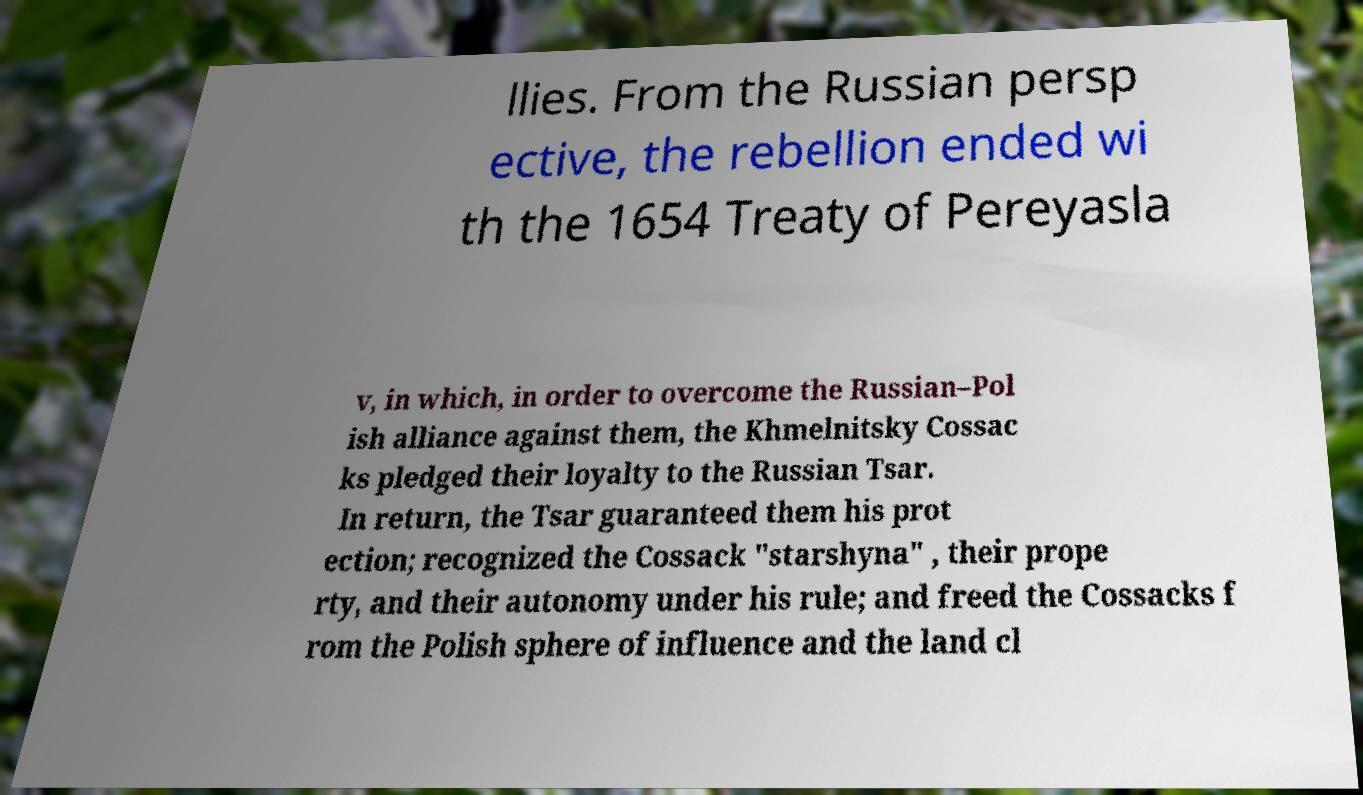Could you assist in decoding the text presented in this image and type it out clearly? llies. From the Russian persp ective, the rebellion ended wi th the 1654 Treaty of Pereyasla v, in which, in order to overcome the Russian–Pol ish alliance against them, the Khmelnitsky Cossac ks pledged their loyalty to the Russian Tsar. In return, the Tsar guaranteed them his prot ection; recognized the Cossack "starshyna" , their prope rty, and their autonomy under his rule; and freed the Cossacks f rom the Polish sphere of influence and the land cl 